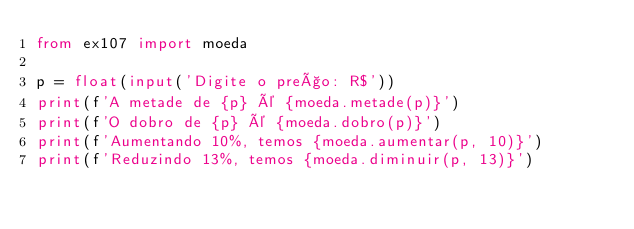Convert code to text. <code><loc_0><loc_0><loc_500><loc_500><_Python_>from ex107 import moeda

p = float(input('Digite o preço: R$'))
print(f'A metade de {p} é {moeda.metade(p)}')
print(f'O dobro de {p} é {moeda.dobro(p)}')
print(f'Aumentando 10%, temos {moeda.aumentar(p, 10)}')
print(f'Reduzindo 13%, temos {moeda.diminuir(p, 13)}')
</code> 